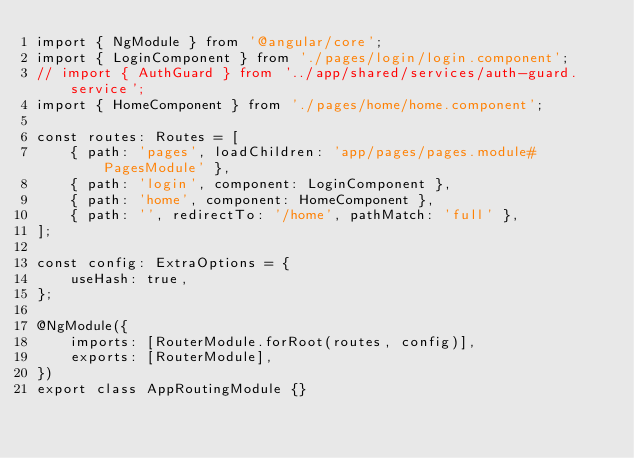Convert code to text. <code><loc_0><loc_0><loc_500><loc_500><_TypeScript_>import { NgModule } from '@angular/core';
import { LoginComponent } from './pages/login/login.component';
// import { AuthGuard } from '../app/shared/services/auth-guard.service';
import { HomeComponent } from './pages/home/home.component';

const routes: Routes = [
    { path: 'pages', loadChildren: 'app/pages/pages.module#PagesModule' },
    { path: 'login', component: LoginComponent },
    { path: 'home', component: HomeComponent },
    { path: '', redirectTo: '/home', pathMatch: 'full' },
];

const config: ExtraOptions = {
    useHash: true,
};

@NgModule({
    imports: [RouterModule.forRoot(routes, config)],
    exports: [RouterModule],
})
export class AppRoutingModule {}
</code> 